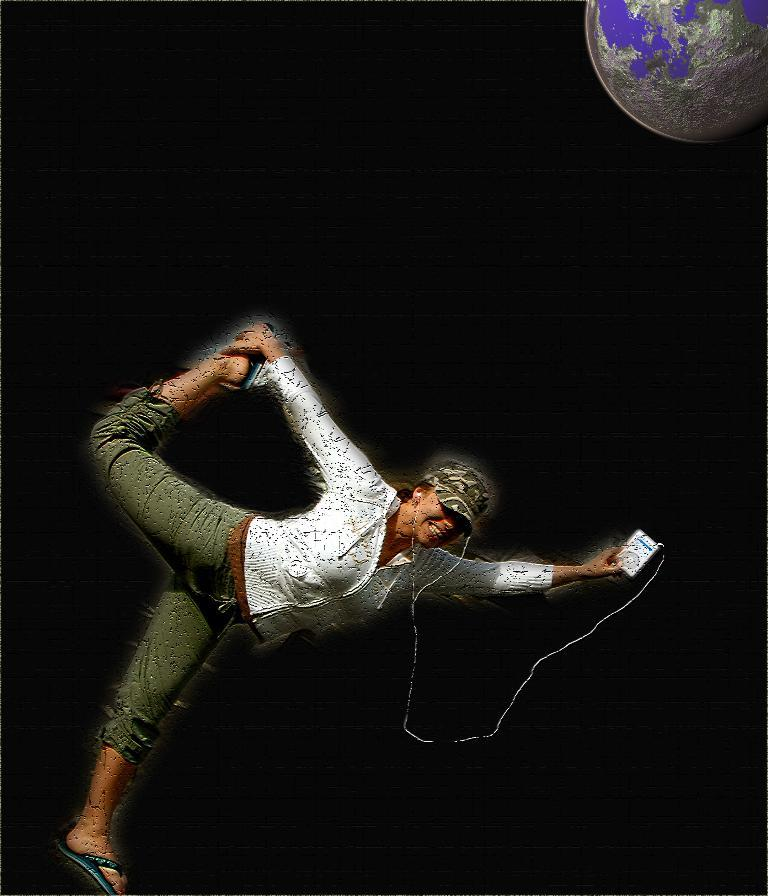What can be seen in the image? There is a person in the image. What is the person wearing? The person is wearing headphones. What is the person holding? The person is holding an object. How would you describe the background of the image? The background of the image is dark. What additional detail can be observed in the top right corner of the image? There is a globe in the top right corner of the image. What type of transport is the person using in the image? There is no transport visible in the image; the person is stationary. What kind of field can be seen in the background of the image? There is no field present in the image; the background is dark. 